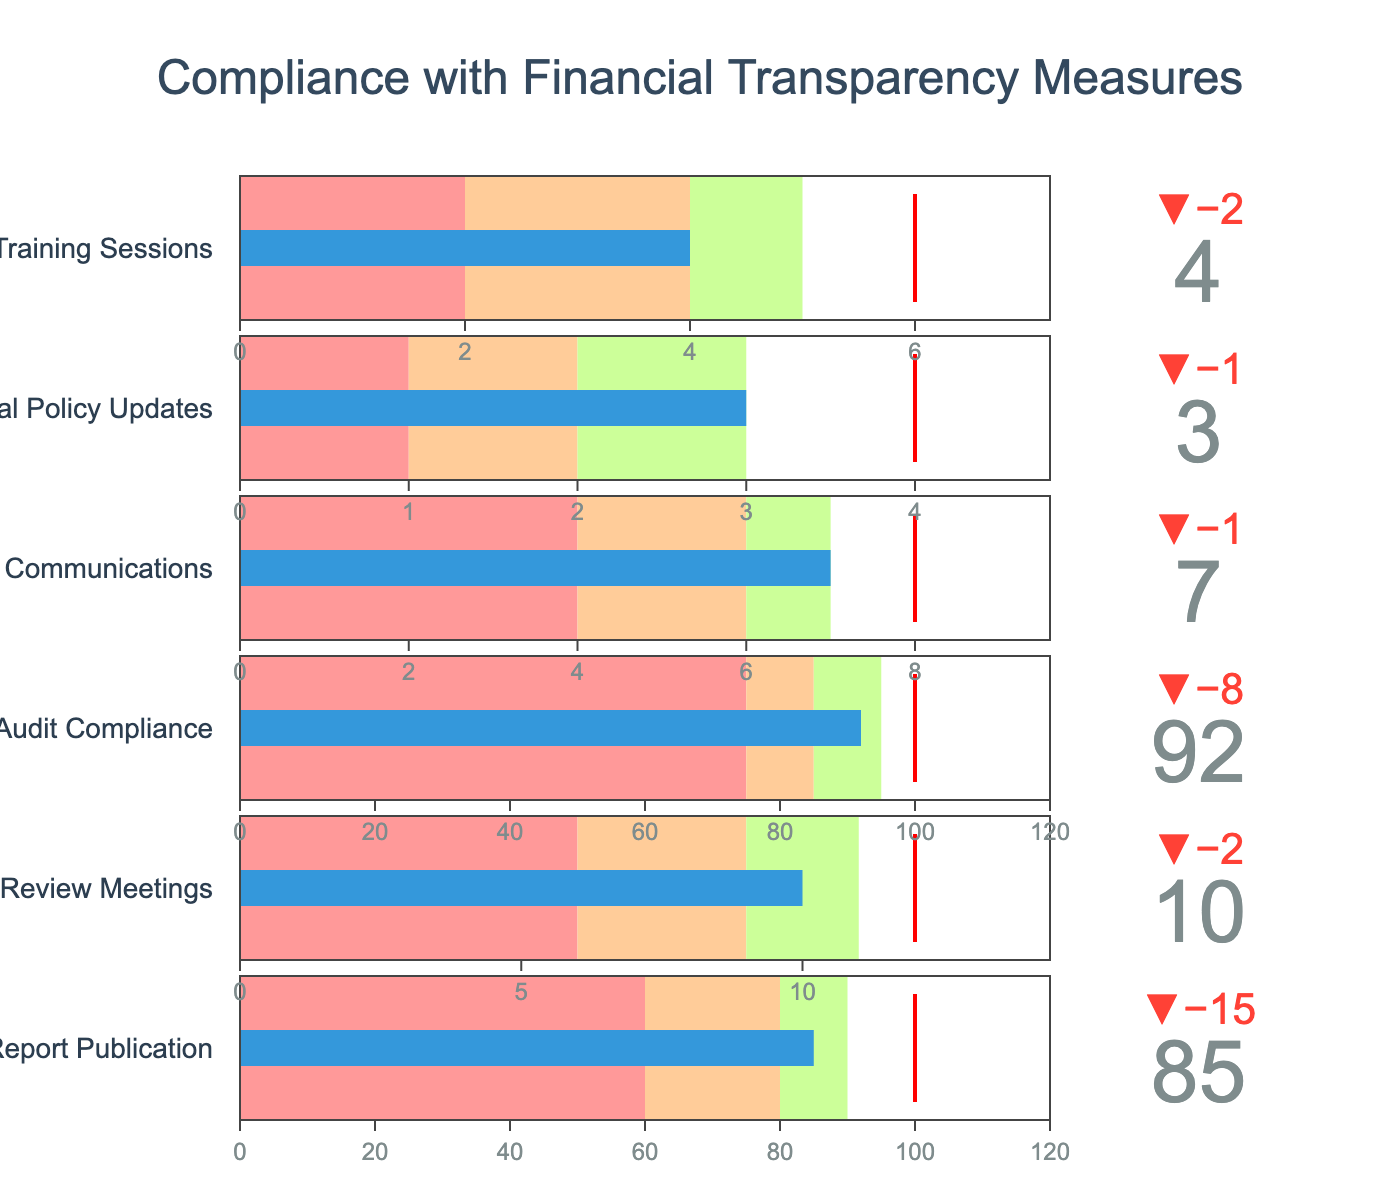What is the title of the bullet chart? The title is located at the top of the chart, and it reads "Compliance with Financial Transparency Measures".
Answer: Compliance with Financial Transparency Measures How many categories are displayed in the bullet chart? The bullet chart contains six indicators, each representing a different category, listed vertically from top to bottom.
Answer: 6 Which category has the highest actual value, and what is it? By comparing the actual values represented by the blue bars in each category, the "External Audit Compliance" category has the highest actual value, which is 92.
Answer: External Audit Compliance, 92 Compare "Board Financial Review Meetings" and "Donor Transparency Communications" based on their actual values. Which one is higher and by how much? The "Board Financial Review Meetings" has an actual value of 10, and "Donor Transparency Communications" is 7. Subtracting these gives 10 - 7 = 3. Hence, "Board Financial Review Meetings" is higher by 3.
Answer: Board Financial Review Meetings, by 3 What is the actual value for "Financial Policy Updates" and how does it compare to its target value? The actual value for "Financial Policy Updates" is 3, and its target value is 4. The actual value is 1 less than the target value.
Answer: The actual is 3, which is 1 less than the target In which performance range does "Annual Financial Report Publication" fall based on its actual value? The actual value of "Annual Financial Report Publication" is 85. By comparing to the colored ranges, 85 falls in the range between 80 and 90, corresponding to the yellow-green section (2nd performance range).
Answer: Second performance range What is the difference between the target and actual value for "External Audit Compliance"? The actual value for "External Audit Compliance" is 92, with a target value of 100. The difference is 100 - 92 = 8.
Answer: 8 Which category is closest to meeting its target? By comparing the actual values to their respective target values across all categories, "Donor Transparency Communications" has an actual value of 7 with a target of 8, making it the closest with a difference of 1.
Answer: Donor Transparency Communications Of the categories "Staff Financial Training Sessions" and "Annual Financial Report Publication," which one exceeds its second performance range? By checking the actual values and second performance ranges, "Annual Financial Report Publication" has an actual value of 85, exceeding its second range of 80. "Staff Financial Training Sessions" has an actual value of 4, within its second range of 4. So, "Annual Financial Report Publication" exceeds its second range.
Answer: Annual Financial Report Publication What is the average actual value across all categories? Adding up the actual values: (85 + 10 + 92 + 7 + 3 + 4) = 201. The total number of categories is 6. The average is 201 divided by 6, which equals 33.5.
Answer: 33.5 